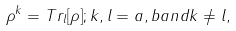Convert formula to latex. <formula><loc_0><loc_0><loc_500><loc_500>\rho ^ { k } = T r _ { l } [ \rho ] ; k , l = a , b a n d k \neq l ,</formula> 